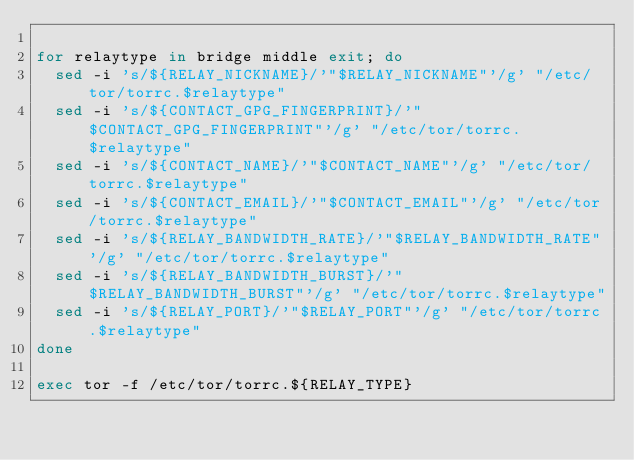<code> <loc_0><loc_0><loc_500><loc_500><_Bash_>
for relaytype in bridge middle exit; do
	sed -i 's/${RELAY_NICKNAME}/'"$RELAY_NICKNAME"'/g' "/etc/tor/torrc.$relaytype"
	sed -i 's/${CONTACT_GPG_FINGERPRINT}/'"$CONTACT_GPG_FINGERPRINT"'/g' "/etc/tor/torrc.$relaytype"
	sed -i 's/${CONTACT_NAME}/'"$CONTACT_NAME"'/g' "/etc/tor/torrc.$relaytype"
	sed -i 's/${CONTACT_EMAIL}/'"$CONTACT_EMAIL"'/g' "/etc/tor/torrc.$relaytype"
	sed -i 's/${RELAY_BANDWIDTH_RATE}/'"$RELAY_BANDWIDTH_RATE"'/g' "/etc/tor/torrc.$relaytype"
	sed -i 's/${RELAY_BANDWIDTH_BURST}/'"$RELAY_BANDWIDTH_BURST"'/g' "/etc/tor/torrc.$relaytype"
	sed -i 's/${RELAY_PORT}/'"$RELAY_PORT"'/g' "/etc/tor/torrc.$relaytype"
done

exec tor -f /etc/tor/torrc.${RELAY_TYPE}
</code> 